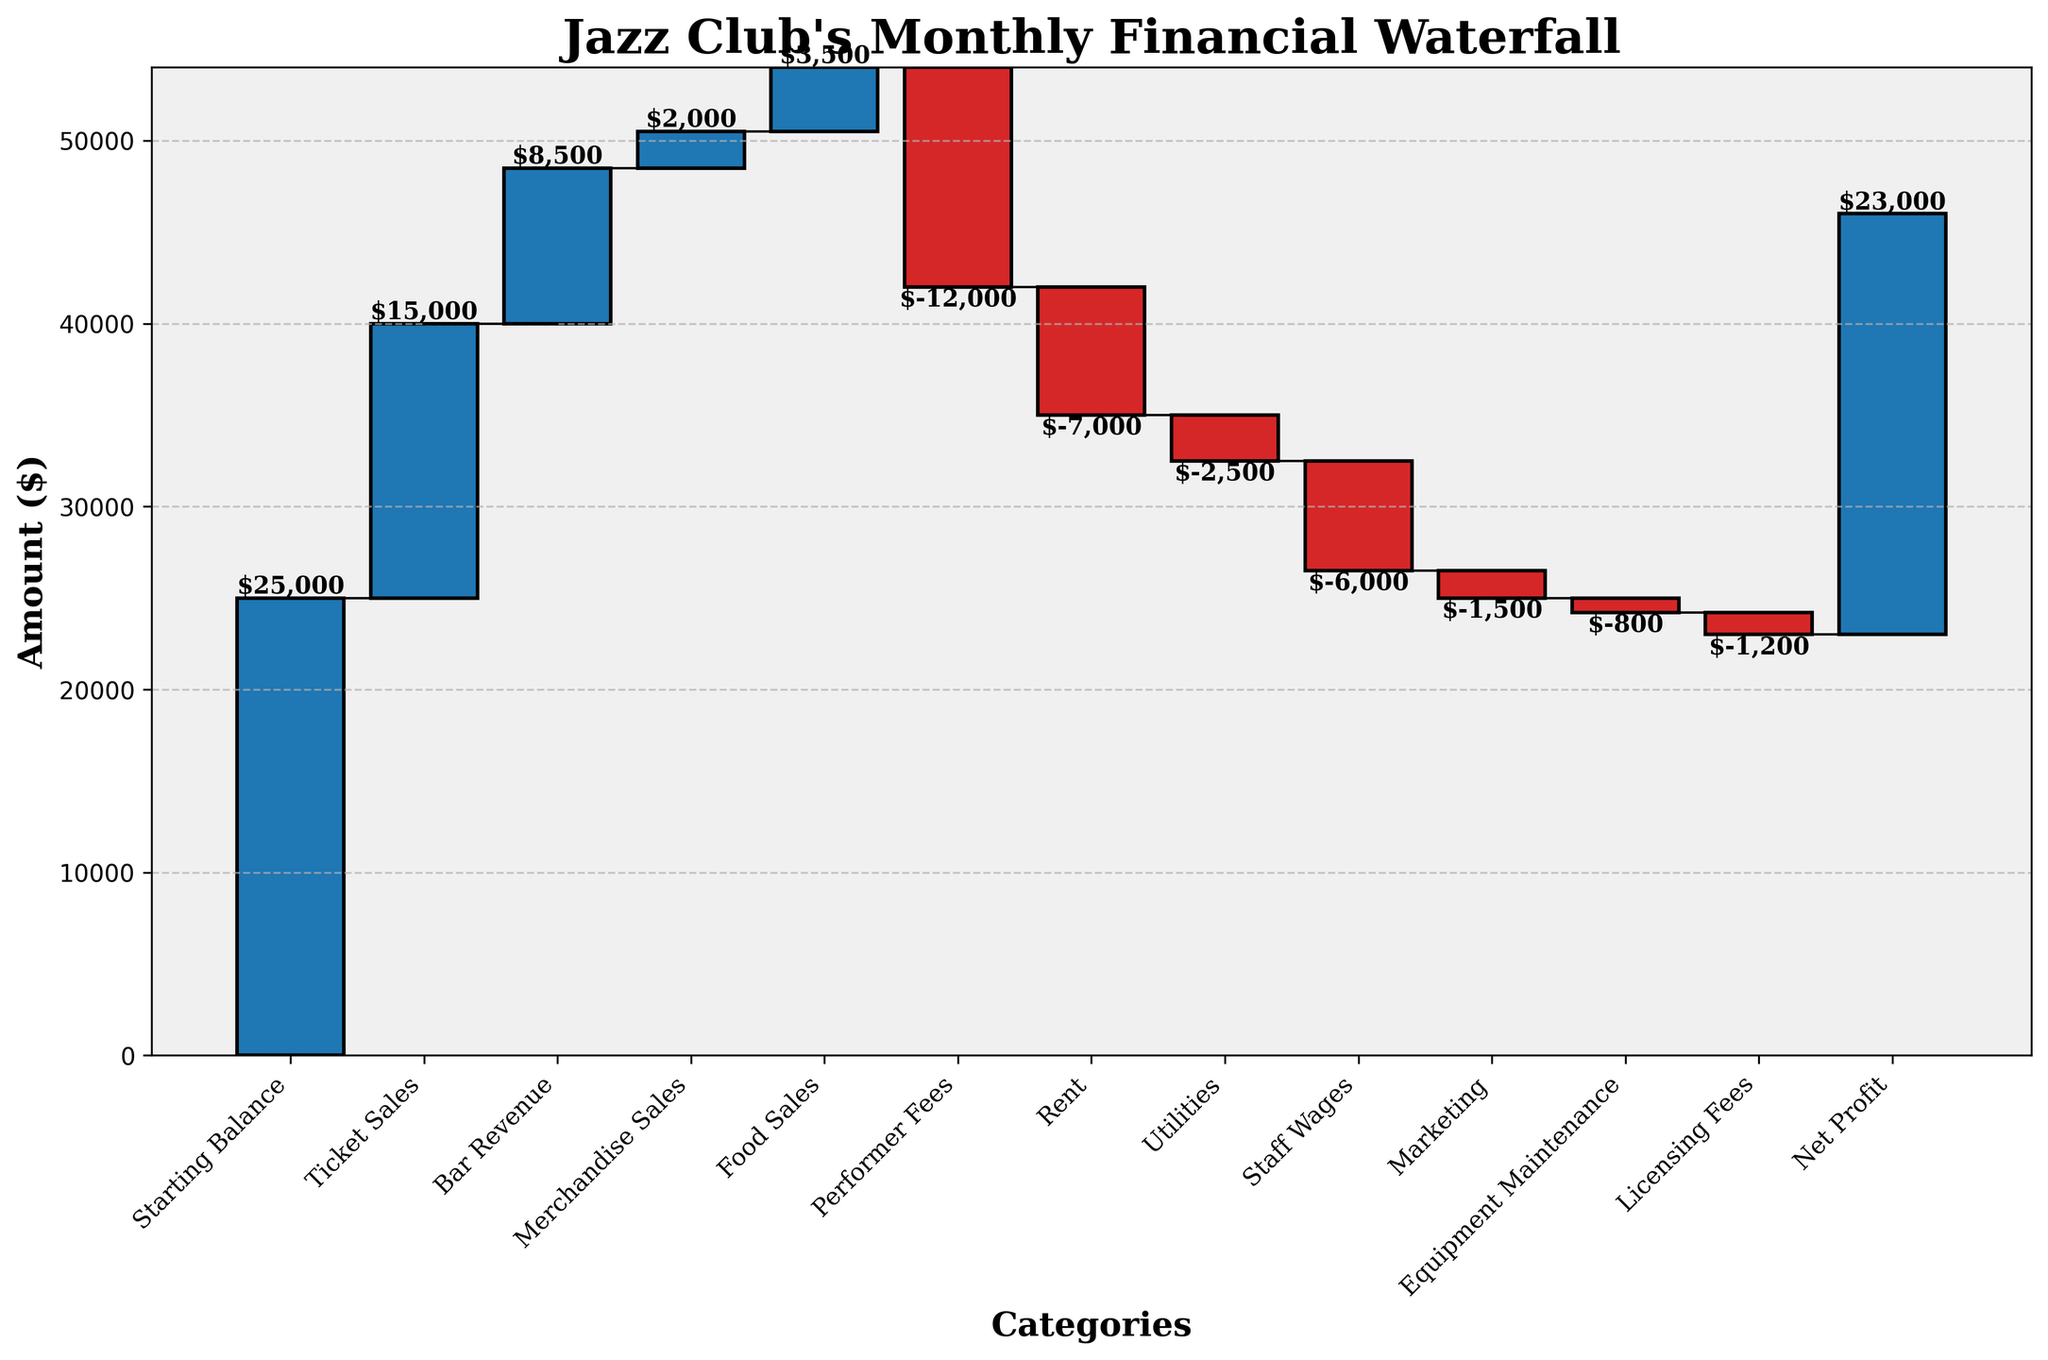What's the title of the chart? The title is displayed at the top of the figure. It is written in a larger and bold font.
Answer: Jazz Club's Monthly Financial Waterfall Which income stream contributes the most to the jazz club? Among all positive contributions, the tallest bar represents the highest income stream.
Answer: Ticket Sales What is the total expense amount for the jazz club? Add up all the negative amounts in the figure: -12000 (Performer Fees) + -7000 (Rent) + -2500 (Utilities) + -6000 (Staff Wages) + -1500 (Marketing) + -800 (Equipment Maintenance) + -1200 (Licensing Fees) = -31000.
Answer: 31000 How does the rent expense compare to the marketing expense? Identify the bars for Rent and Marketing, comparing their heights and values. The Rent bar is taller and has a larger negative value than the Marketing bar.
Answer: Rent is higher What is the overall net profit for the jazz club? The net profit is the last value in the waterfall chart, representing the final accumulation after all income and expenses.
Answer: 23000 Which expense category is the smallest in amount? Among all negative contributions, the smallest and shortest red bar represents the smallest expense.
Answer: Equipment Maintenance What is the cumulative total before deducting performer fees? Sum up the positive amounts up to Performer Fees: 25000 (Starting Balance) + 15000 (Ticket Sales) + 8500 (Bar Revenue) + 2000 (Merchandise Sales) + 3500 (Food Sales) = 54000.
Answer: 54000 Is food sales larger or smaller than merchandise sales? Compare the heights and values of the bars representing Food Sales and Merchandise Sales, where Food Sales is taller and has a larger amount.
Answer: Larger How much revenue did the club generate from non-ticket sources? Sum up non-ticket positive amounts: 8500 (Bar Revenue) + 2000 (Merchandise Sales) + 3500 (Food Sales) = 14000.
Answer: 14000 Which category has almost the same amount as the utilities expense? Compare the heights and values of the bars. Staff Wages and Utilities have closer values, with Staff Wages being slightly larger.
Answer: Staff Wages 